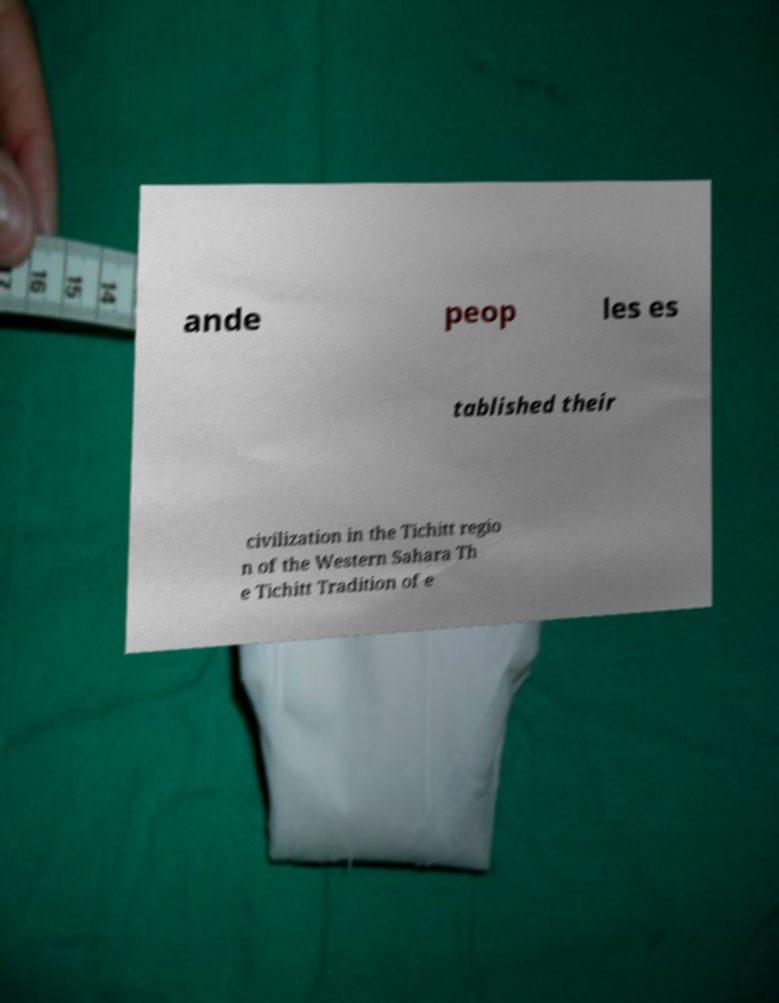Can you accurately transcribe the text from the provided image for me? ande peop les es tablished their civilization in the Tichitt regio n of the Western Sahara Th e Tichitt Tradition of e 